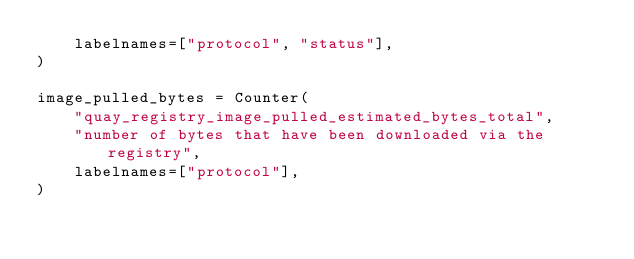Convert code to text. <code><loc_0><loc_0><loc_500><loc_500><_Python_>    labelnames=["protocol", "status"],
)

image_pulled_bytes = Counter(
    "quay_registry_image_pulled_estimated_bytes_total",
    "number of bytes that have been downloaded via the registry",
    labelnames=["protocol"],
)
</code> 